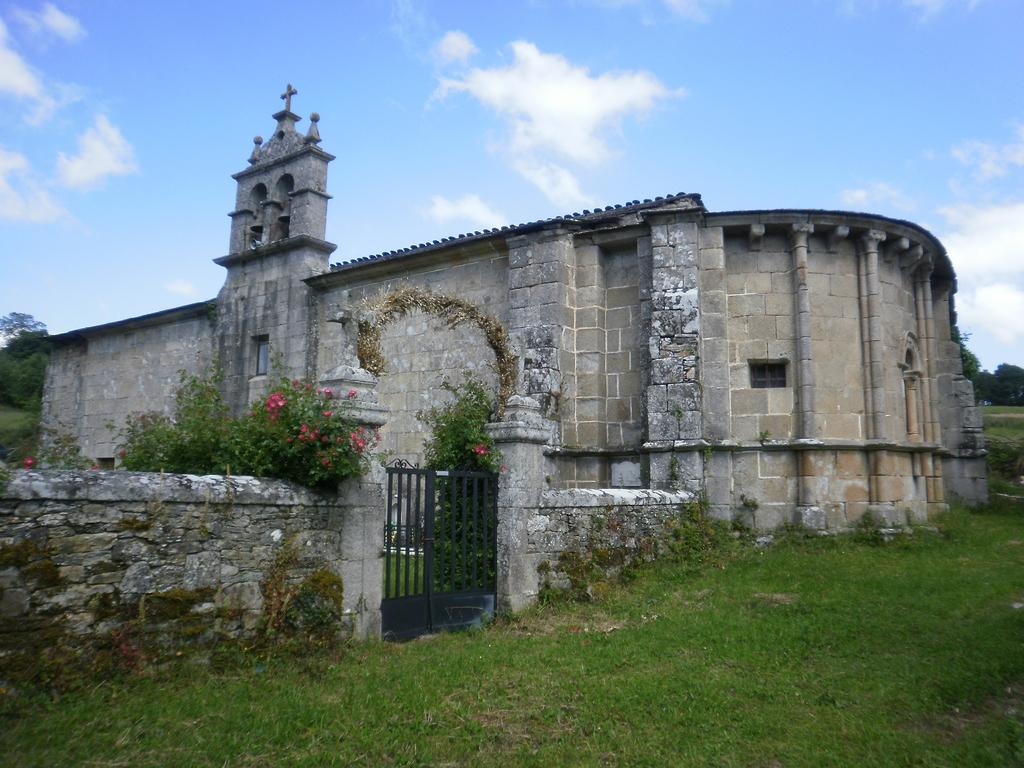What type of structure is present in the image? There is a building in the image. What is the purpose of the barrier in the image? There is a gate in the image, which serves as an entrance or exit. What type of vegetation can be seen in the image? There are plants, grass, flowers, and trees in the image. What is visible in the background of the image? The sky is visible in the background of the image, with clouds present. What color is the vein visible on the skin of the person in the image? There is no person present in the image, and therefore no skin or veins can be observed. 